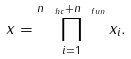Convert formula to latex. <formula><loc_0><loc_0><loc_500><loc_500>x = \prod _ { i = 1 } ^ { n _ { \ h c } + n _ { \ f u n } } x _ { i } .</formula> 